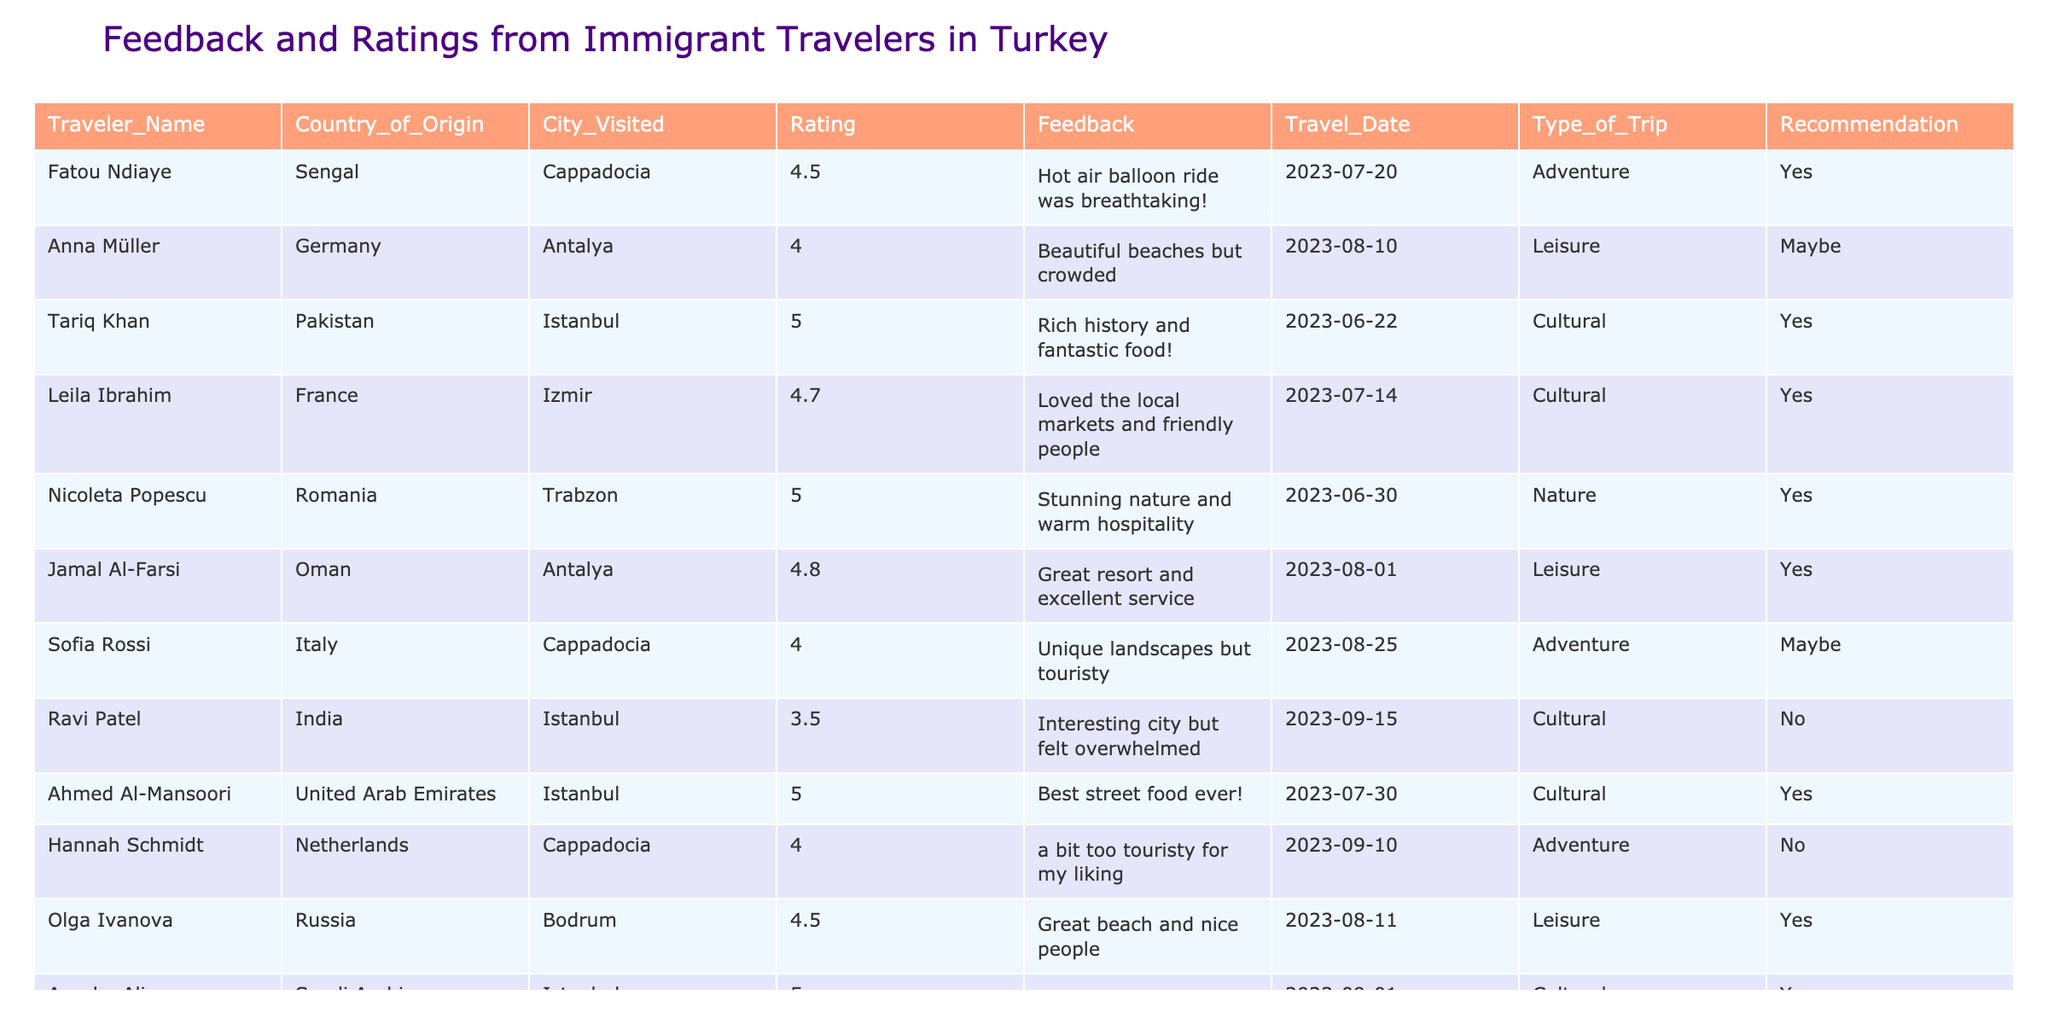What is the highest rating given by a traveler? The table lists several travelers along with their ratings. Scanning through the "Rating" column, the highest value found is 5, provided by multiple travelers.
Answer: 5 How many travelers visited Istanbul? By looking at the table and counting the entries where "City_Visited" is Istanbul, there are four entries.
Answer: 4 What type of trip did Ayesha Ali take? Referring to the row associated with Ayesha Ali, the "Type_of_Trip" column specifies that she took a Cultural trip.
Answer: Cultural Among all trips, which city received the least average rating? To find the city with the least average rating, we calculate the average ratings for each city: Cappadocia (4.2), Antalya (4.4), Istanbul (4.1), Izmir (4.7), and Trabzon (5). Istanbul has the lowest average rating.
Answer: Istanbul Did any traveler recommend their trip to Bodrum? By inspecting the "Recommendation" column for the entry corresponding to Bodrum, it is evident that Olga Ivanova indicated "Yes" for her trip.
Answer: Yes Which traveler had the most positive feedback and what did they say? Scanning through the table, Tariq Khan had a rating of 5, and his feedback was "Rich history and fantastic food!"
Answer: Tariq Khan: "Rich history and fantastic food!" What is the average rating for all trips listed? First, we sum the ratings: (4.5 + 4 + 5 + 4.7 + 5 + 4.8 + 4 + 3.5 + 5 + 4 + 5 + 3) = 55. The total number of ratings is 12, therefore the average rating is 55/12 ≈ 4.58.
Answer: 4.58 Which country of origin has the highest average rating? Calculate the average rating for each country by taking the ratings for travelers from the same country: Senegal (4.5), Germany (3.5), Pakistan (5), France (4.7), Romania (5), Oman (4.8), Italy (4), India (3.5), UAE (5), and Saudi Arabia (5). The UAE, Pakistan, Saudi Arabia, and Romania each have a rating of 5, which is the highest.
Answer: UAE, Pakistan, Saudi Arabia, Romania What was the date of the trip that received the lowest rating? The lowest rating in the table is 3, corresponding to Ravi Patel's trip to Istanbul, which took place on 2023-09-15.
Answer: 2023-09-15 Is there a traveler from Saudi Arabia who recommended their trip? Looking at the row for Ayesha Ali from Saudi Arabia, we can see that she did indeed recommend her trip with a "Yes".
Answer: Yes 